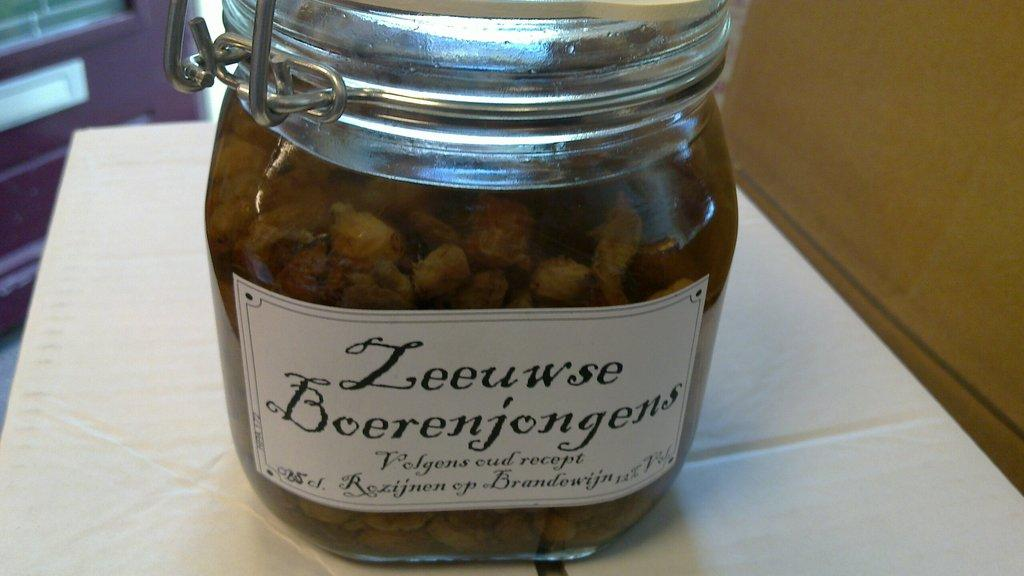<image>
Offer a succinct explanation of the picture presented. Leeuwse Boerenjongens Volgens cud recept in a silver and clear jar. 